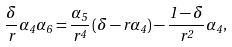Convert formula to latex. <formula><loc_0><loc_0><loc_500><loc_500>\frac { \delta } { r } \alpha _ { 4 } \alpha _ { 6 } = \frac { \alpha _ { 5 } } { r ^ { 4 } } \left ( \delta - r \alpha _ { 4 } \right ) - \frac { 1 - \delta } { r ^ { 2 } } \alpha _ { 4 } ,</formula> 